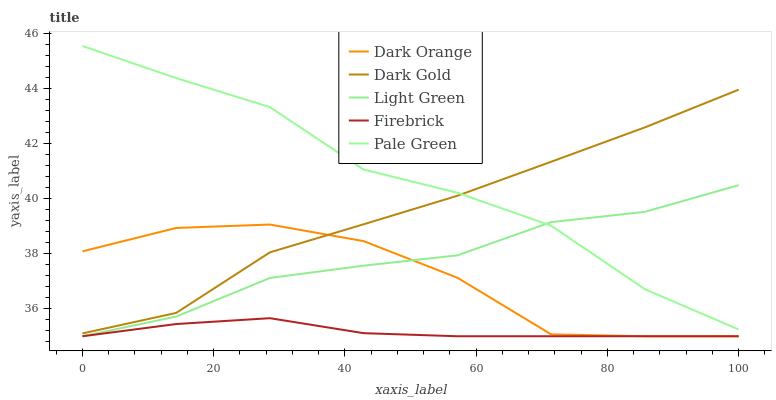Does Firebrick have the minimum area under the curve?
Answer yes or no. Yes. Does Pale Green have the maximum area under the curve?
Answer yes or no. Yes. Does Pale Green have the minimum area under the curve?
Answer yes or no. No. Does Firebrick have the maximum area under the curve?
Answer yes or no. No. Is Firebrick the smoothest?
Answer yes or no. Yes. Is Pale Green the roughest?
Answer yes or no. Yes. Is Pale Green the smoothest?
Answer yes or no. No. Is Firebrick the roughest?
Answer yes or no. No. Does Dark Orange have the lowest value?
Answer yes or no. Yes. Does Pale Green have the lowest value?
Answer yes or no. No. Does Pale Green have the highest value?
Answer yes or no. Yes. Does Firebrick have the highest value?
Answer yes or no. No. Is Firebrick less than Dark Gold?
Answer yes or no. Yes. Is Pale Green greater than Firebrick?
Answer yes or no. Yes. Does Pale Green intersect Dark Gold?
Answer yes or no. Yes. Is Pale Green less than Dark Gold?
Answer yes or no. No. Is Pale Green greater than Dark Gold?
Answer yes or no. No. Does Firebrick intersect Dark Gold?
Answer yes or no. No. 